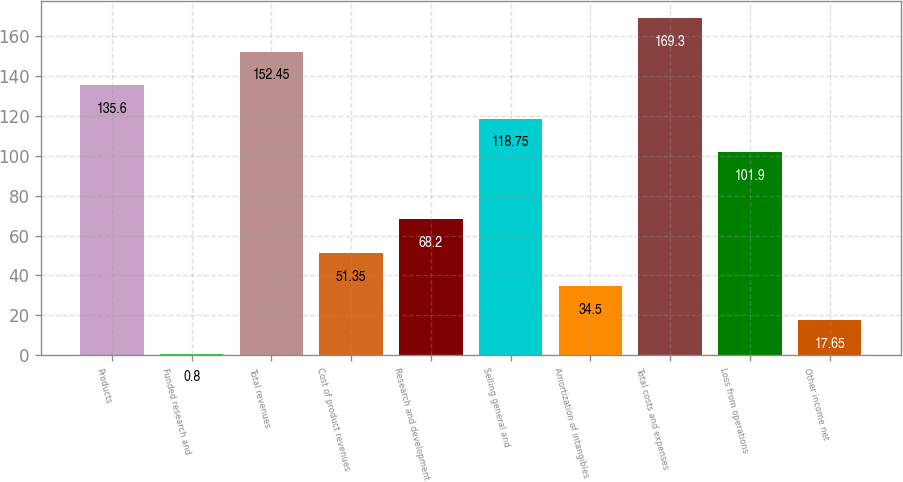<chart> <loc_0><loc_0><loc_500><loc_500><bar_chart><fcel>Products<fcel>Funded research and<fcel>Total revenues<fcel>Cost of product revenues<fcel>Research and development<fcel>Selling general and<fcel>Amortization of intangibles<fcel>Total costs and expenses<fcel>Loss from operations<fcel>Other income net<nl><fcel>135.6<fcel>0.8<fcel>152.45<fcel>51.35<fcel>68.2<fcel>118.75<fcel>34.5<fcel>169.3<fcel>101.9<fcel>17.65<nl></chart> 